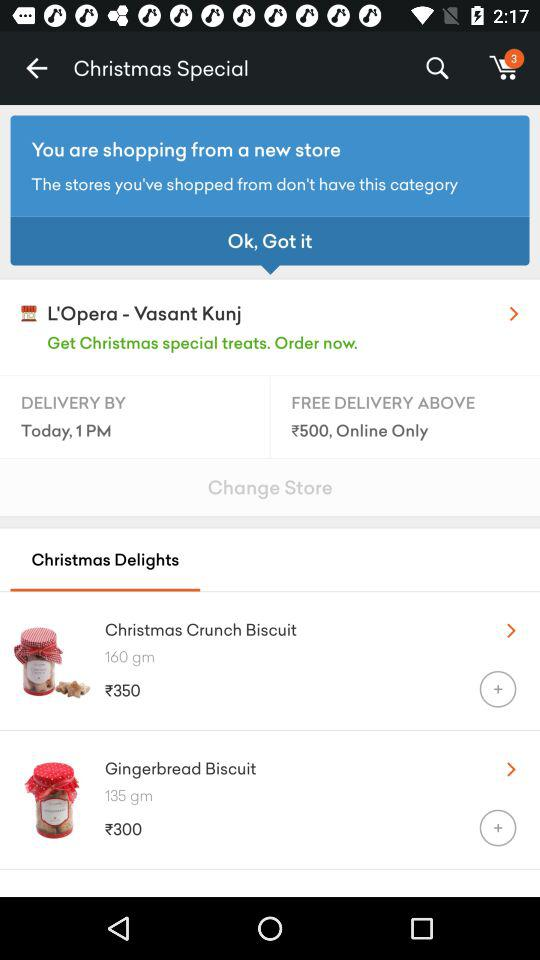What is the price of "Christmas Crunch Biscuit"? The price of "Christmas Crunch Biscuit" is ₹350. 